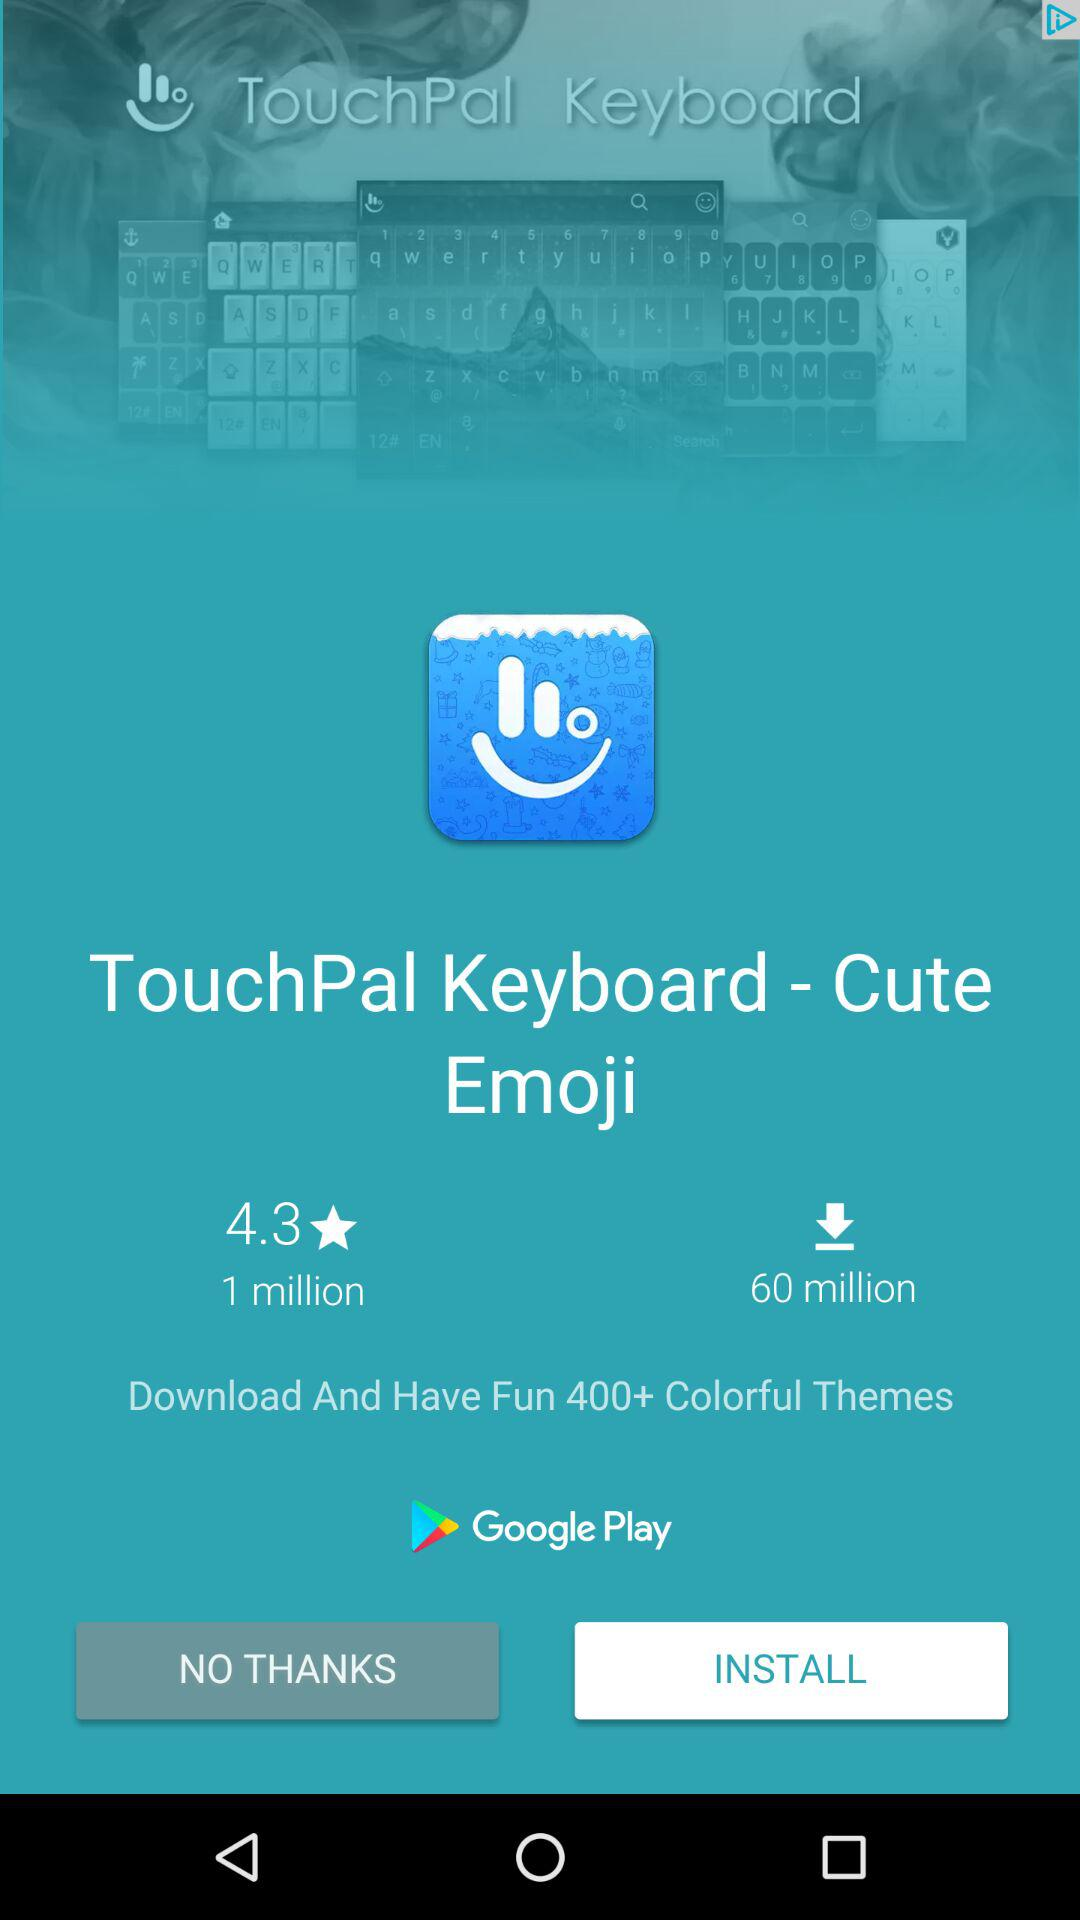How many more downloads does the app have than the number of reviews?
Answer the question using a single word or phrase. 59 million 